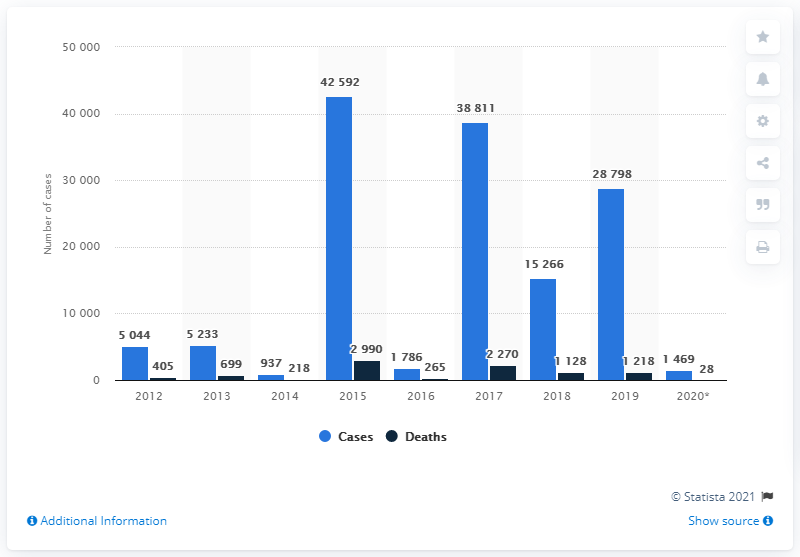Point out several critical features in this image. According to the information available, a total of 28 individuals in India lost their lives due to swine flu between January and March 2020. 